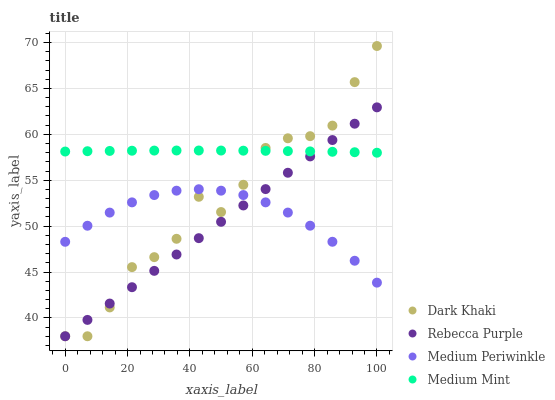Does Rebecca Purple have the minimum area under the curve?
Answer yes or no. Yes. Does Medium Mint have the maximum area under the curve?
Answer yes or no. Yes. Does Medium Periwinkle have the minimum area under the curve?
Answer yes or no. No. Does Medium Periwinkle have the maximum area under the curve?
Answer yes or no. No. Is Rebecca Purple the smoothest?
Answer yes or no. Yes. Is Dark Khaki the roughest?
Answer yes or no. Yes. Is Medium Mint the smoothest?
Answer yes or no. No. Is Medium Mint the roughest?
Answer yes or no. No. Does Dark Khaki have the lowest value?
Answer yes or no. Yes. Does Medium Periwinkle have the lowest value?
Answer yes or no. No. Does Dark Khaki have the highest value?
Answer yes or no. Yes. Does Medium Mint have the highest value?
Answer yes or no. No. Is Medium Periwinkle less than Medium Mint?
Answer yes or no. Yes. Is Medium Mint greater than Medium Periwinkle?
Answer yes or no. Yes. Does Rebecca Purple intersect Medium Periwinkle?
Answer yes or no. Yes. Is Rebecca Purple less than Medium Periwinkle?
Answer yes or no. No. Is Rebecca Purple greater than Medium Periwinkle?
Answer yes or no. No. Does Medium Periwinkle intersect Medium Mint?
Answer yes or no. No. 